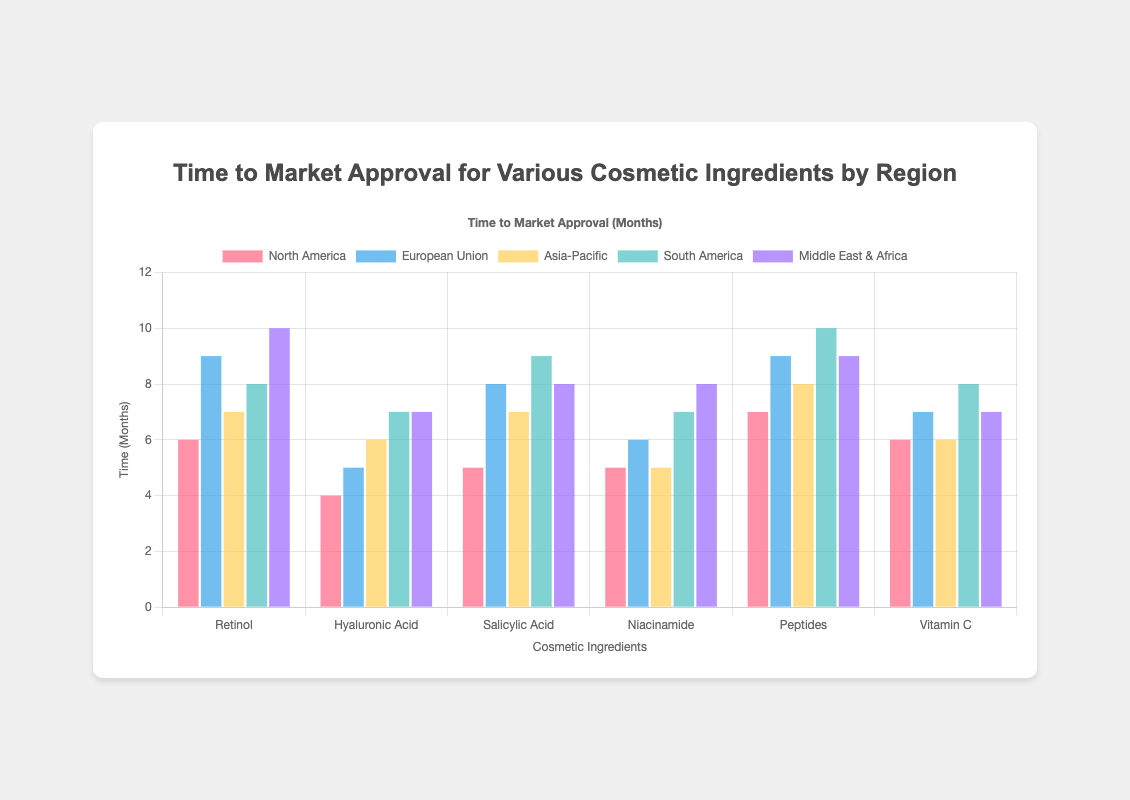Which region has the longest approval time for Retinol? To find the region with the longest approval time for Retinol, look at the respective bars for Retinol and compare their heights. The tallest bar represents the longest approval time, which in this case is the Middle East & Africa with 10 months.
Answer: Middle East & Africa Which ingredient has the shortest approval time in North America? Check the bars for North America data across all ingredients. The shortest bar corresponds to Hyaluronic Acid with an approval time of 4 months.
Answer: Hyaluronic Acid Compare the approval times for Vitamin C in North America and South America. Which region has a shorter approval time, and by how many months? Look at the bars for Vitamin C in North America and South America. The North America bar is at 6 months, and the South America bar is at 8 months. The approval time is shorter in North America by 2 months.
Answer: North America, 2 months What is the average approval time for Salicylic Acid across all regions? Add up the approval times for Salicylic Acid across all regions: 5 (North America) + 8 (European Union) + 7 (Asia-Pacific) + 9 (South America) + 8 (Middle East & Africa). The total is 37. Divide by the number of regions, which is 5: 37 / 5 = 7.4 months.
Answer: 7.4 months Which ingredient has the highest approval time variability among the regions, and what is the range? Compare the range (max-min) of approval times for each ingredient. Peptides has the highest range: min is 7 (North America), max is 10 (South America), giving a range of 10 - 7 = 3 months.
Answer: Peptides, 3 months Is the approval time for Hyaluronic Acid the same in any two regions? Check if there are any identical bar heights for Hyaluronic Acid across regions. The Middle East & Africa and South America both have an approval time of 7 months.
Answer: Yes, Middle East & Africa and South America For Niacinamide, which region has a higher approval time compared to Asia-Pacific, and by how much? Compare the bar height for Niacinamide in Asia-Pacific (5 months) with other regions. South America and Middle East & Africa have higher approval times of 7 and 8 months respectively.
Answer: South America by 2 months, Middle East & Africa by 3 months What is the total combined approval time for all ingredients in the European Union? Sum the approval times for all ingredients in the European Union: 9 (Retinol) + 5 (Hyaluronic Acid) + 8 (Salicylic Acid) + 6 (Niacinamide) + 9 (Peptides) + 7 (Vitamin C). Total is 44 months.
Answer: 44 months How do the approval times for Peptides in South America compare to those in North America? Look at the heights of the Peptides bars for North America and South America. South America has 10 months and North America has 7 months. South America has a longer approval time by 3 months.
Answer: South America, 3 months What is the median approval time for Niacinamide across all regions? Organize the approval times of Niacinamide in ascending order: 5 (Asia-Pacific), 5 (North America), 6 (European Union), 7 (South America), 8 (Middle East & Africa). The median is the third value, which is 6 months.
Answer: 6 months 